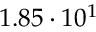<formula> <loc_0><loc_0><loc_500><loc_500>1 . 8 5 \cdot 1 0 ^ { 1 }</formula> 